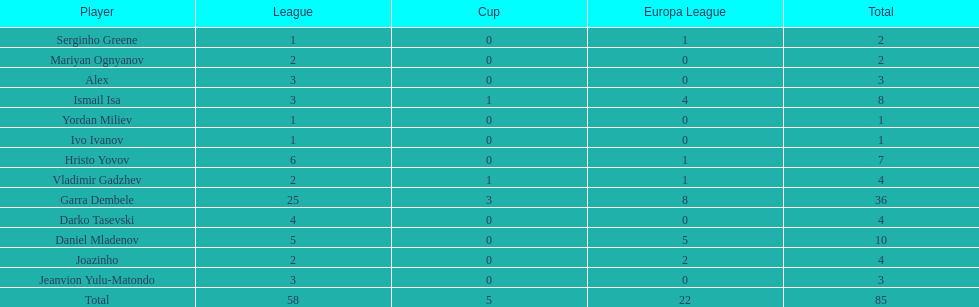Which is the only player from germany? Jeanvion Yulu-Matondo. 